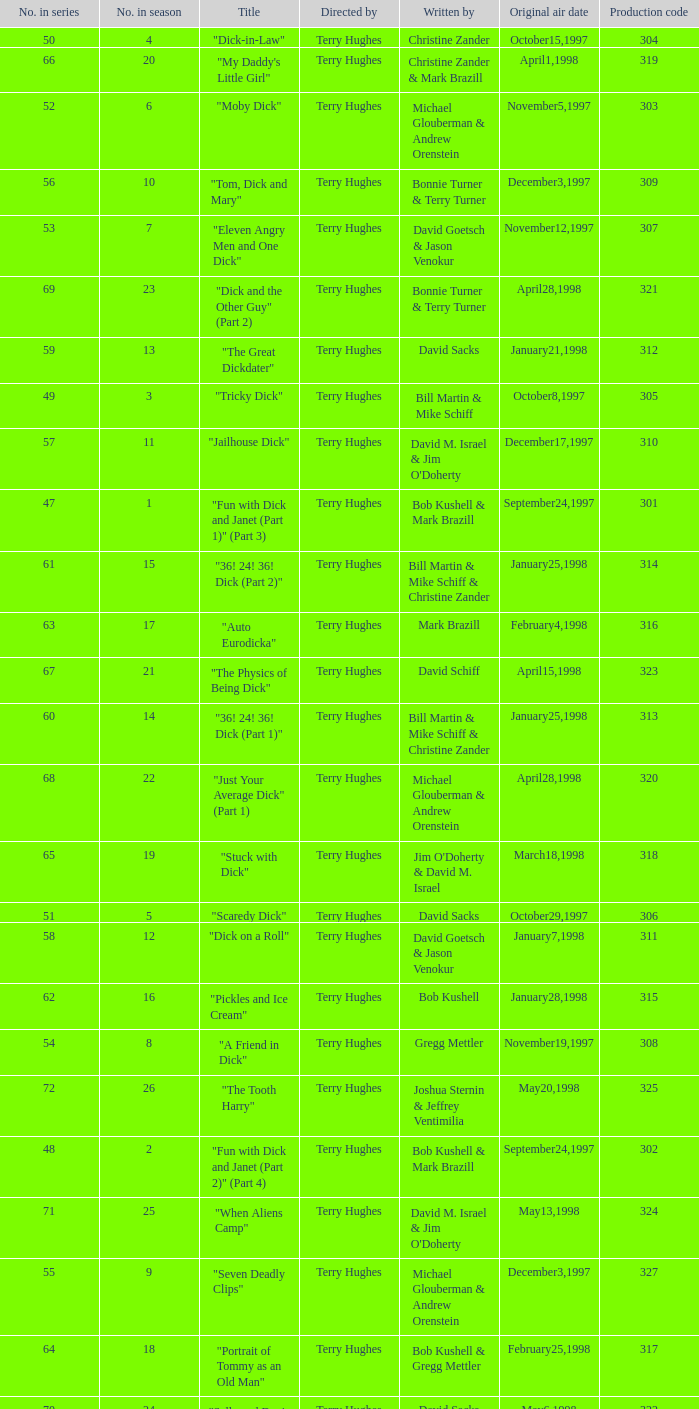Who were the writers of the episode titled "Tricky Dick"? Bill Martin & Mike Schiff. 